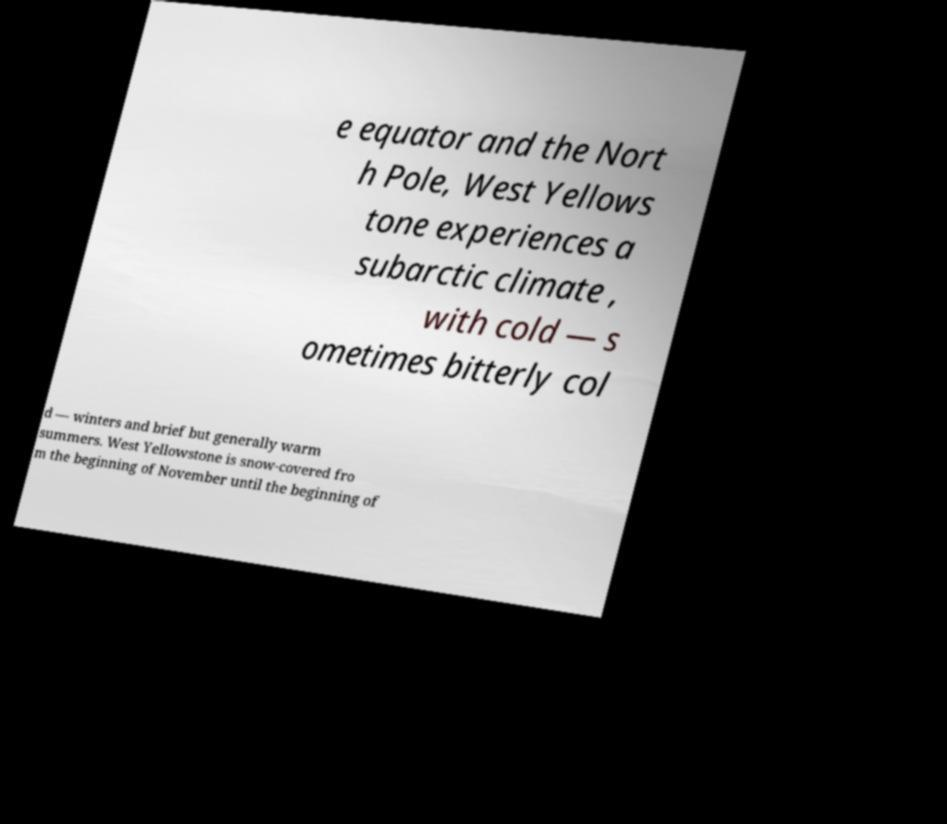I need the written content from this picture converted into text. Can you do that? e equator and the Nort h Pole, West Yellows tone experiences a subarctic climate , with cold — s ometimes bitterly col d — winters and brief but generally warm summers. West Yellowstone is snow-covered fro m the beginning of November until the beginning of 